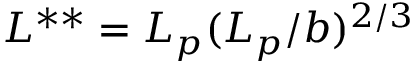Convert formula to latex. <formula><loc_0><loc_0><loc_500><loc_500>L ^ { * * } = L _ { p } ( L _ { p } / b ) ^ { 2 / 3 }</formula> 